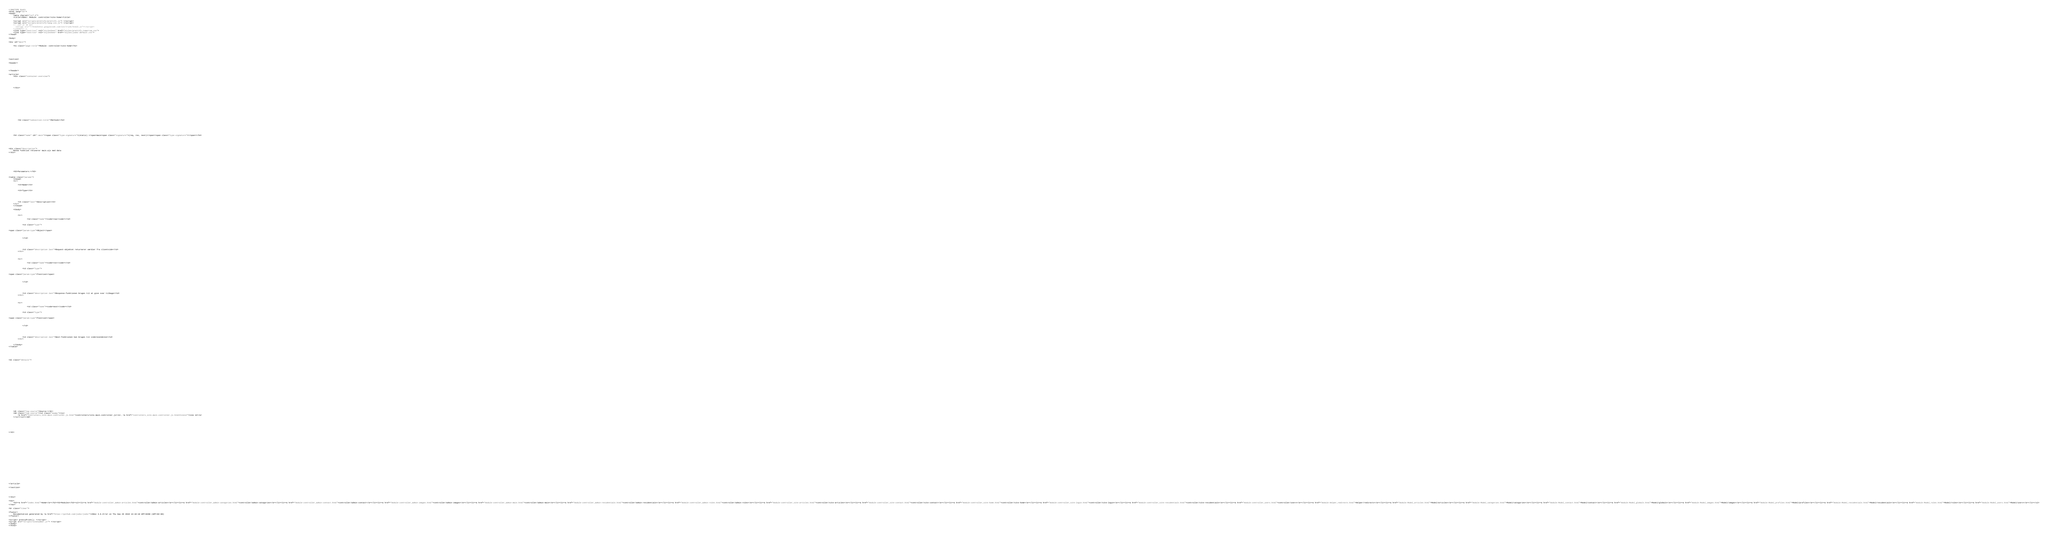Convert code to text. <code><loc_0><loc_0><loc_500><loc_500><_HTML_><!DOCTYPE html>
<html lang="en">
<head>
    <meta charset="utf-8">
    <title>JSDoc: Module: controller/site-home</title>

    <script src="scripts/prettify/prettify.js"> </script>
    <script src="scripts/prettify/lang-css.js"> </script>
    <!--[if lt IE 9]>
      <script src="//html5shiv.googlecode.com/svn/trunk/html5.js"></script>
    <![endif]-->
    <link type="text/css" rel="stylesheet" href="styles/prettify-tomorrow.css">
    <link type="text/css" rel="stylesheet" href="styles/jsdoc-default.css">
</head>

<body>

<div id="main">

    <h1 class="page-title">Module: controller/site-home</h1>

    




<section>

<header>
    
        
    
</header>

<article>
    <div class="container-overview">
    
        

        
    
    </div>

    

    

    

    

    

    

    

    
        <h3 class="subsection-title">Methods</h3>

        
            

    

    
    <h4 class="name" id=".main"><span class="type-signature">(static) </span>main<span class="signature">(req, res, next)</span><span class="type-signature"></span></h4>
    

    



<div class="description">
    Denne funktion retunerer main.ejs med data
</div>









    <h5>Parameters:</h5>
    

<table class="params">
    <thead>
    <tr>
        
        <th>Name</th>
        

        <th>Type</th>

        

        

        <th class="last">Description</th>
    </tr>
    </thead>

    <tbody>
    

        <tr>
            
                <td class="name"><code>req</code></td>
            

            <td class="type">
            
                
<span class="param-type">Object</span>


            
            </td>

            

            

            <td class="description last">Request-objektet returnerer værdier fra clientside</td>
        </tr>

    

        <tr>
            
                <td class="name"><code>res</code></td>
            

            <td class="type">
            
                
<span class="param-type">function</span>


            
            </td>

            

            

            <td class="description last">Response-funktionen bruges til at give svar tilbage</td>
        </tr>

    

        <tr>
            
                <td class="name"><code>next</code></td>
            

            <td class="type">
            
                
<span class="param-type">function</span>


            
            </td>

            

            

            <td class="description last">Next-funktionen kan bruges til videresendelse</td>
        </tr>

    
    </tbody>
</table>






<dl class="details">

    

    

    

    

    

    

    

    

    

    

    

    

    
    <dt class="tag-source">Source:</dt>
    <dd class="tag-source"><ul class="dummy"><li>
        <a href="controllers_site.main.controller.js.html">controllers/site.main.controller.js</a>, <a href="controllers_site.main.controller.js.html#line12">line 12</a>
    </li></ul></dd>
    

    

    

    
</dl>




















        
    

    

    
</article>

</section>




</div>

<nav>
    <h2><a href="index.html">Home</a></h2><h3>Modules</h3><ul><li><a href="module-controller_admin-articles.html">controller/admin-articles</a></li><li><a href="module-controller_admin-categories.html">controller/admin-categories</a></li><li><a href="module-controller_admin-contact.html">controller/admin-contact</a></li><li><a href="module-controller_admin-images.html">controller/admin-images</a></li><li><a href="module-controller_admin-main.html">controller/admin-main</a></li><li><a href="module-controller_admin-residentials.html">controller/admin-residentials</a></li><li><a href="module-controller_admin-roles.html">controller/admin-roles</a></li><li><a href="module-controller_site-articles.html">controller/site-articles</a></li><li><a href="module-controller_site-contact.html">controller/site-contact</a></li><li><a href="module-controller_site-home.html">controller/site-home</a></li><li><a href="module-controller_site-login.html">controller/site-login</a></li><li><a href="module-controller_site-residentials.html">controller/site-residentials</a></li><li><a href="module-controller_users.html">controller/users</a></li><li><a href="module-Helper_redirects.html">Helper/redirects</a></li><li><a href="module-Model_articles.html">Model/articles</a></li><li><a href="module-Model_categories.html">Model/categories</a></li><li><a href="module-Model_contact.html">Model/contact</a></li><li><a href="module-Model_globals.html">Model/globals</a></li><li><a href="module-Model_images.html">Model/images</a></li><li><a href="module-Model_profiles.html">Model/profiles</a></li><li><a href="module-Model_residentials.html">Model/residentials</a></li><li><a href="module-Model_roles.html">Model/roles</a></li><li><a href="module-Model_users.html">Model/users</a></li></ul>
</nav>

<br class="clear">

<footer>
    Documentation generated by <a href="https://github.com/jsdoc/jsdoc">JSDoc 3.6.3</a> on Thu Sep 26 2019 13:18:10 GMT+0200 (GMT+02:00)
</footer>

<script> prettyPrint(); </script>
<script src="scripts/linenumber.js"> </script>
</body>
</html></code> 